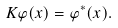<formula> <loc_0><loc_0><loc_500><loc_500>K \varphi ( x ) = \varphi ^ { * } ( x ) .</formula> 